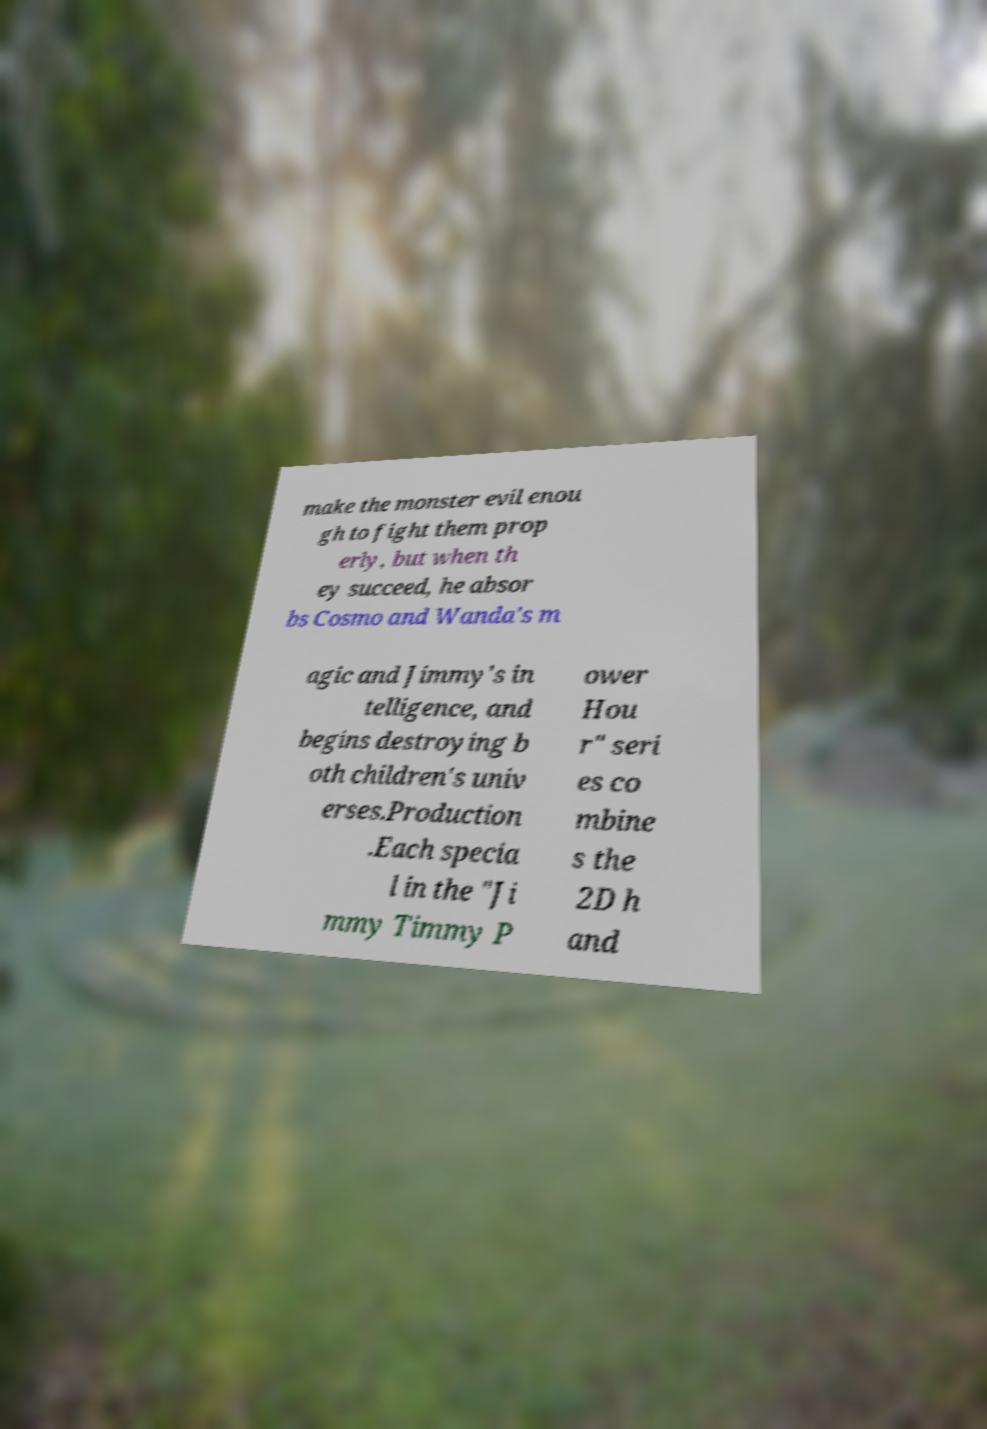Please read and relay the text visible in this image. What does it say? make the monster evil enou gh to fight them prop erly, but when th ey succeed, he absor bs Cosmo and Wanda's m agic and Jimmy's in telligence, and begins destroying b oth children's univ erses.Production .Each specia l in the "Ji mmy Timmy P ower Hou r" seri es co mbine s the 2D h and 